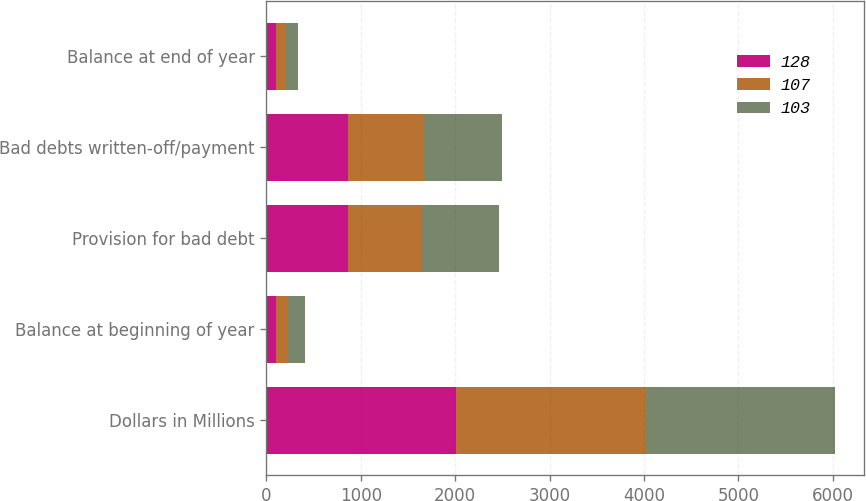Convert chart to OTSL. <chart><loc_0><loc_0><loc_500><loc_500><stacked_bar_chart><ecel><fcel>Dollars in Millions<fcel>Balance at beginning of year<fcel>Provision for bad debt<fcel>Bad debts written-off/payment<fcel>Balance at end of year<nl><fcel>128<fcel>2010<fcel>103<fcel>864<fcel>860<fcel>107<nl><fcel>107<fcel>2009<fcel>128<fcel>776<fcel>800<fcel>103<nl><fcel>103<fcel>2008<fcel>180<fcel>829<fcel>835<fcel>128<nl></chart> 